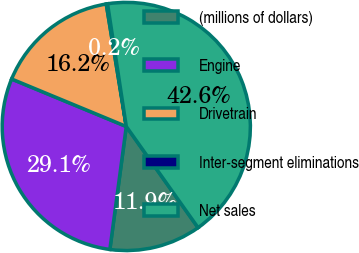<chart> <loc_0><loc_0><loc_500><loc_500><pie_chart><fcel>(millions of dollars)<fcel>Engine<fcel>Drivetrain<fcel>Inter-segment eliminations<fcel>Net sales<nl><fcel>11.93%<fcel>29.13%<fcel>16.17%<fcel>0.17%<fcel>42.59%<nl></chart> 